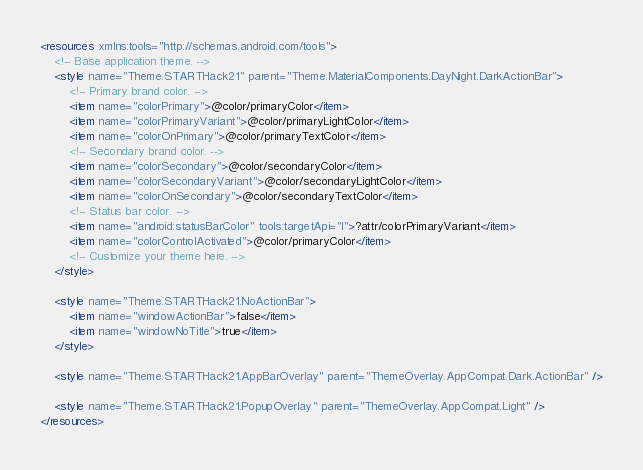<code> <loc_0><loc_0><loc_500><loc_500><_XML_><resources xmlns:tools="http://schemas.android.com/tools">
    <!-- Base application theme. -->
    <style name="Theme.STARTHack21" parent="Theme.MaterialComponents.DayNight.DarkActionBar">
        <!-- Primary brand color. -->
        <item name="colorPrimary">@color/primaryColor</item>
        <item name="colorPrimaryVariant">@color/primaryLightColor</item>
        <item name="colorOnPrimary">@color/primaryTextColor</item>
        <!-- Secondary brand color. -->
        <item name="colorSecondary">@color/secondaryColor</item>
        <item name="colorSecondaryVariant">@color/secondaryLightColor</item>
        <item name="colorOnSecondary">@color/secondaryTextColor</item>
        <!-- Status bar color. -->
        <item name="android:statusBarColor" tools:targetApi="l">?attr/colorPrimaryVariant</item>
        <item name="colorControlActivated">@color/primaryColor</item>
        <!-- Customize your theme here. -->
    </style>

    <style name="Theme.STARTHack21.NoActionBar">
        <item name="windowActionBar">false</item>
        <item name="windowNoTitle">true</item>
    </style>

    <style name="Theme.STARTHack21.AppBarOverlay" parent="ThemeOverlay.AppCompat.Dark.ActionBar" />

    <style name="Theme.STARTHack21.PopupOverlay" parent="ThemeOverlay.AppCompat.Light" />
</resources></code> 